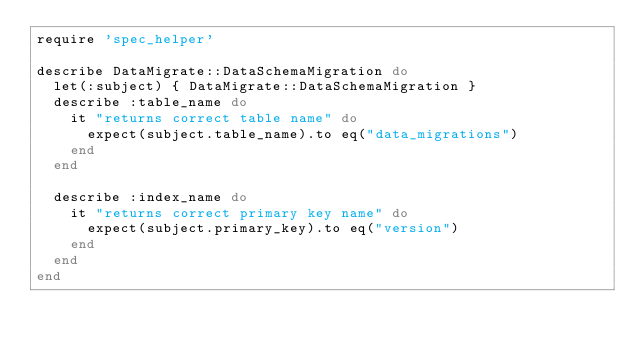<code> <loc_0><loc_0><loc_500><loc_500><_Ruby_>require 'spec_helper'

describe DataMigrate::DataSchemaMigration do
  let(:subject) { DataMigrate::DataSchemaMigration }
  describe :table_name do
    it "returns correct table name" do
      expect(subject.table_name).to eq("data_migrations")
    end
  end

  describe :index_name do
    it "returns correct primary key name" do
      expect(subject.primary_key).to eq("version")
    end
  end
end
</code> 